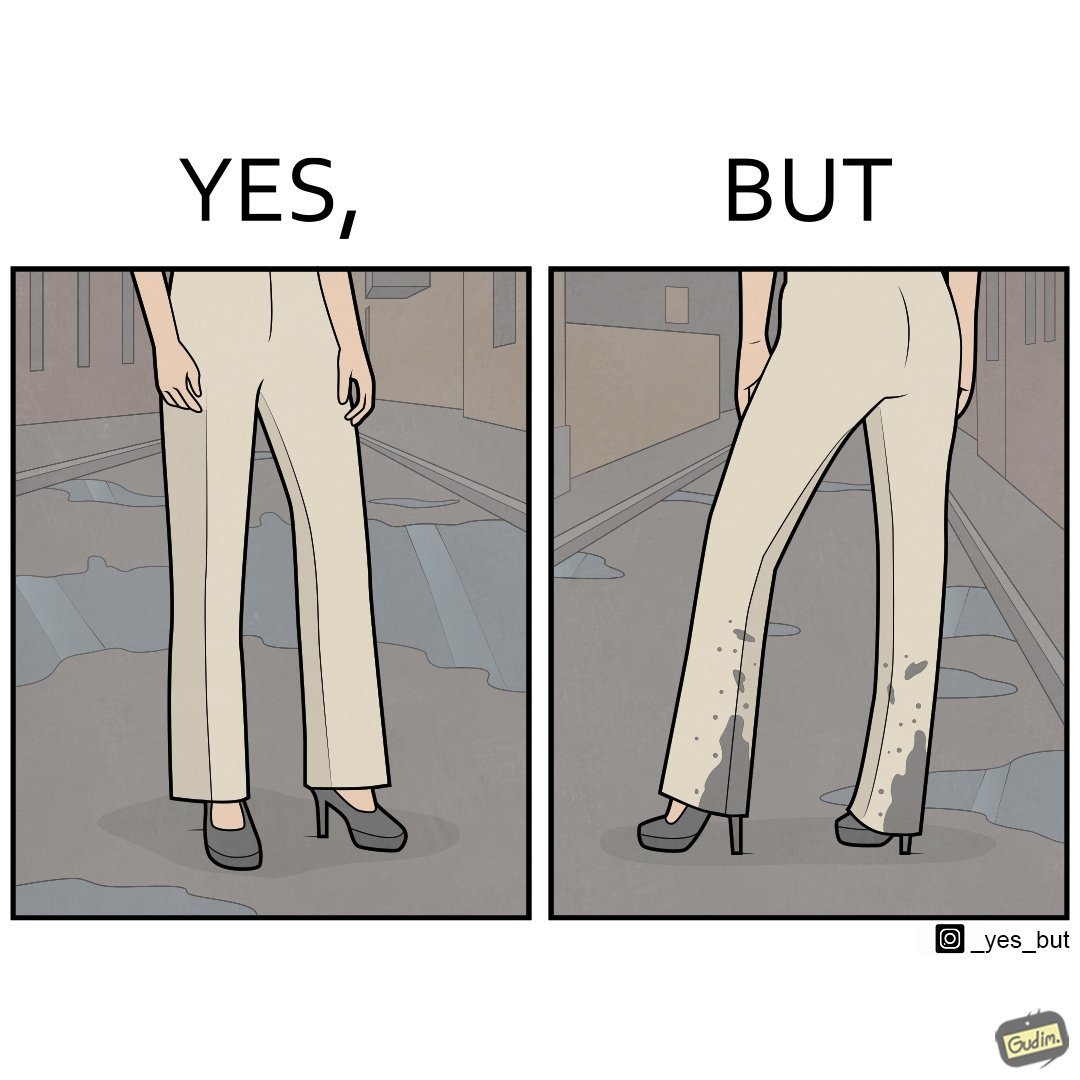Is this a satirical image? Yes, this image is satirical. 